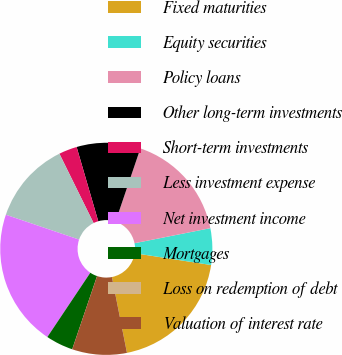Convert chart. <chart><loc_0><loc_0><loc_500><loc_500><pie_chart><fcel>Fixed maturities<fcel>Equity securities<fcel>Policy loans<fcel>Other long-term investments<fcel>Short-term investments<fcel>Less investment expense<fcel>Net investment income<fcel>Mortgages<fcel>Loss on redemption of debt<fcel>Valuation of interest rate<nl><fcel>19.44%<fcel>5.56%<fcel>16.67%<fcel>9.72%<fcel>2.78%<fcel>12.5%<fcel>20.83%<fcel>4.17%<fcel>0.0%<fcel>8.33%<nl></chart> 